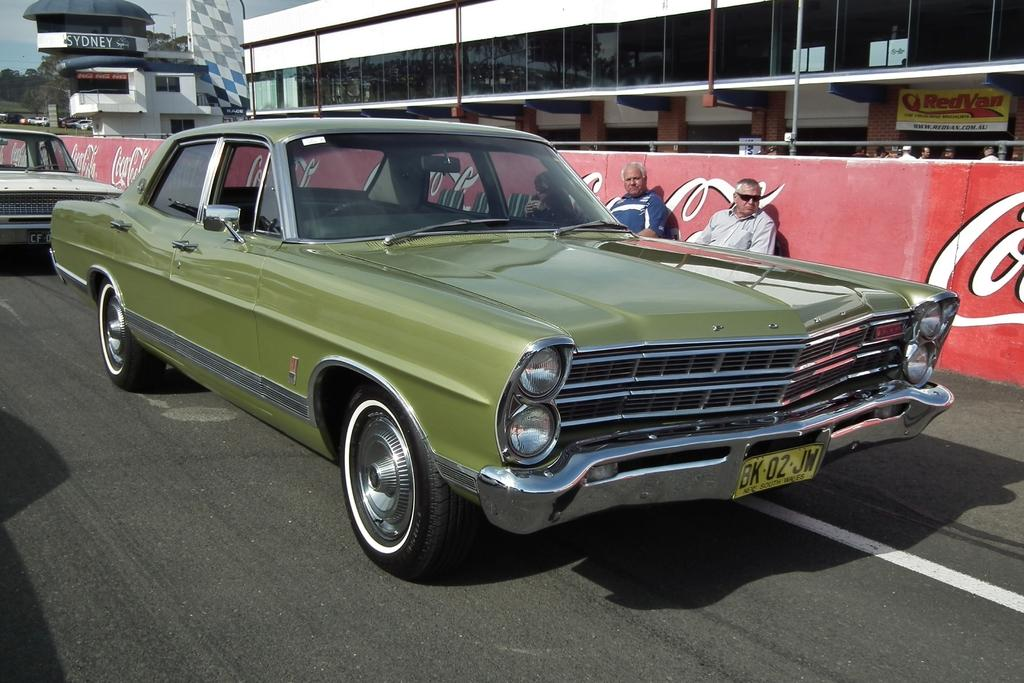What can be seen on the road in the image? There are cars on the road in the image. How many people are sitting in the image? There are two people sitting in the image. What is visible behind the two people? There is a hoarding visible behind the two people. What can be seen in the background of the image? There are buildings, trees, boards, vehicles, and the sky visible in the background of the image. Can you see any geese swimming in the sea in the image? There is no sea or geese present in the image. What type of bit is being used by the people in the image? There is no bit present in the image, and the people are not using any bit. 